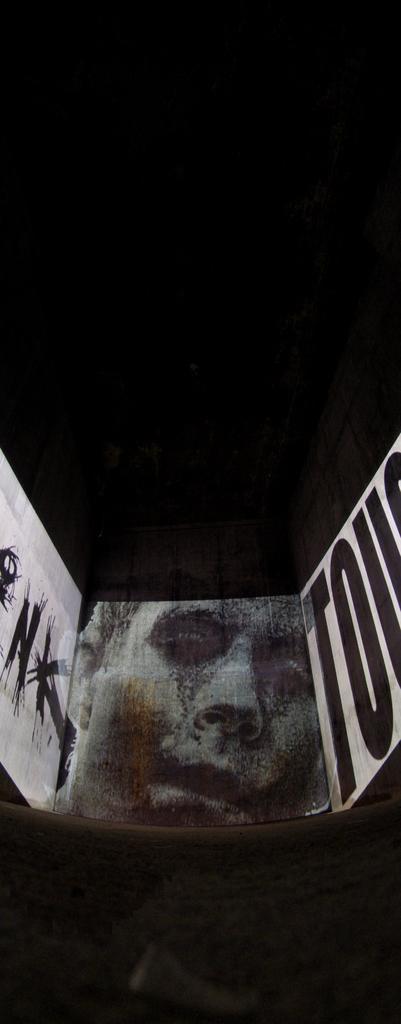Describe this image in one or two sentences. In this image we can see the picture and some text on a wall. 